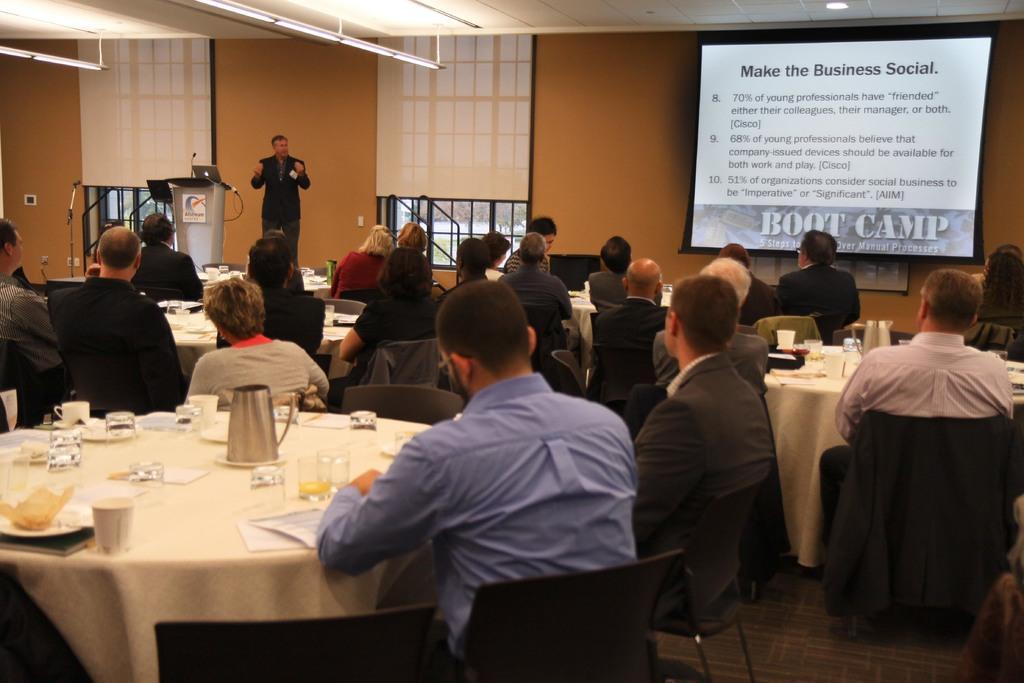Could you give a brief overview of what you see in this image? There are many people sitting on chairs. There is a table. A kettle, glass , plate, paper and cup are over there on the table. And there is a person standing in the background. And a podium is over there. On the wall there are window. And a screen is there on the wall. 